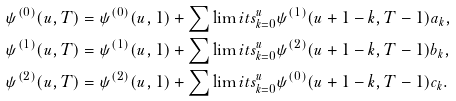<formula> <loc_0><loc_0><loc_500><loc_500>\psi ^ { ( 0 ) } ( u , T ) & = \psi ^ { ( 0 ) } ( u , 1 ) + \sum \lim i t s _ { k = 0 } ^ { u } \psi ^ { ( 1 ) } ( u + 1 - k , T - 1 ) a _ { k } , \\ \psi ^ { ( 1 ) } ( u , T ) & = \psi ^ { ( 1 ) } ( u , 1 ) + \sum \lim i t s _ { k = 0 } ^ { u } \psi ^ { ( 2 ) } ( u + 1 - k , T - 1 ) b _ { k } , \\ \psi ^ { ( 2 ) } ( u , T ) & = \psi ^ { ( 2 ) } ( u , 1 ) + \sum \lim i t s _ { k = 0 } ^ { u } \psi ^ { ( 0 ) } ( u + 1 - k , T - 1 ) c _ { k } .</formula> 